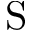Convert formula to latex. <formula><loc_0><loc_0><loc_500><loc_500>S</formula> 